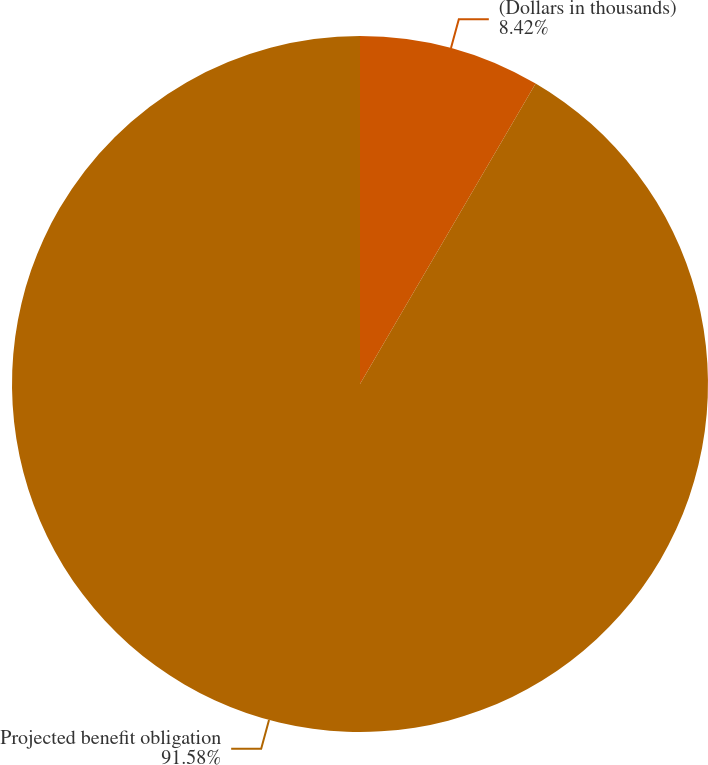<chart> <loc_0><loc_0><loc_500><loc_500><pie_chart><fcel>(Dollars in thousands)<fcel>Projected benefit obligation<nl><fcel>8.42%<fcel>91.58%<nl></chart> 